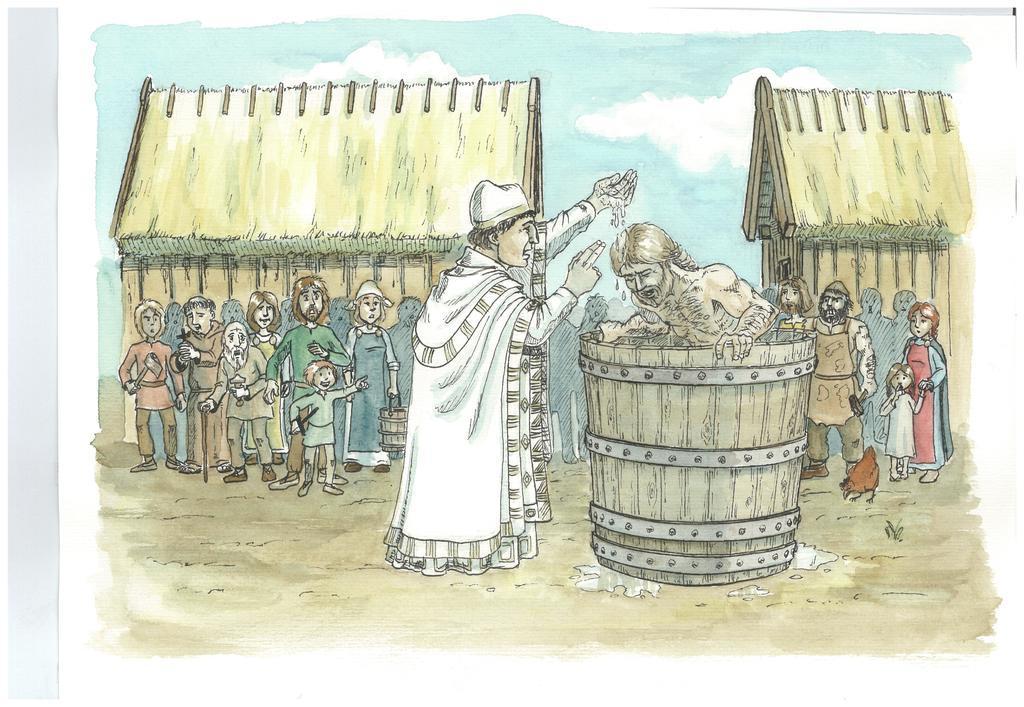Can you describe this image briefly? In the image we can see there is a person standing in the wooden water drum and there is a man standing on the ground. The man is pouring water on the person standing in the wooden water drum and there are spectators standing and watching them. Behind there are two huts and there is a cloudy sky. There is a hen standing on the ground. 